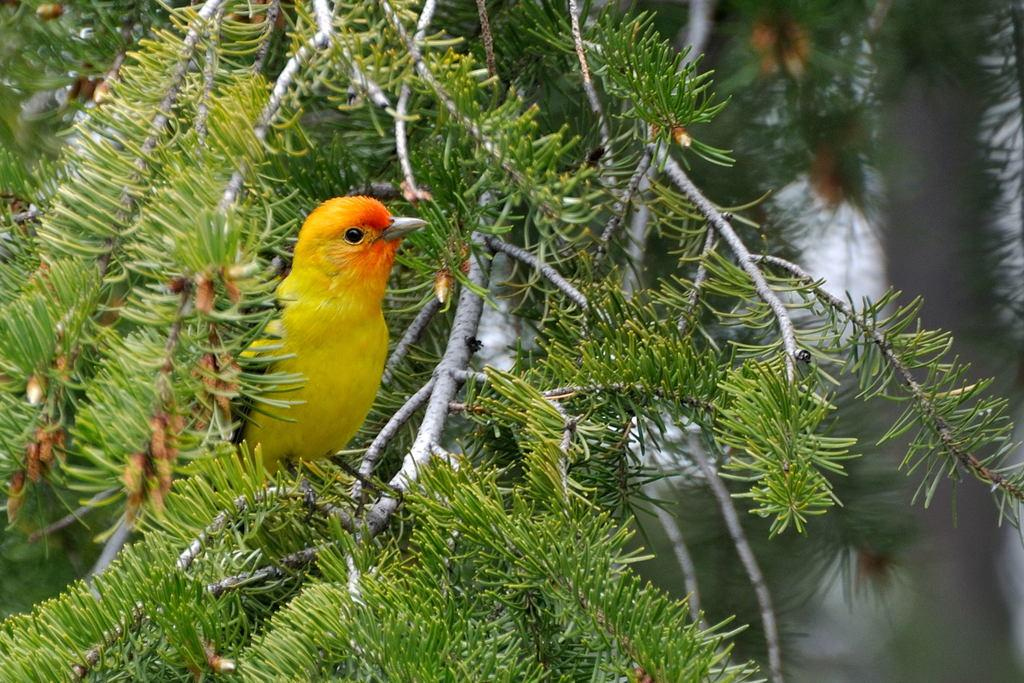What type of animal can be seen in the image? There is a bird in the image. Where is the bird located? The bird is on a tree branch. What can be seen on the tree in the image? There are leaves visible in the image. What is visible in the background of the image? There appears to be water in the background of the image. What type of basin is used for distributing fear in the image? There is no basin or distribution of fear present in the image; it features a bird on a tree branch with leaves and water in the background. 